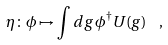<formula> <loc_0><loc_0><loc_500><loc_500>\eta \colon \phi \mapsto \int d g \, \phi ^ { \dag } U ( g ) \ \ ,</formula> 